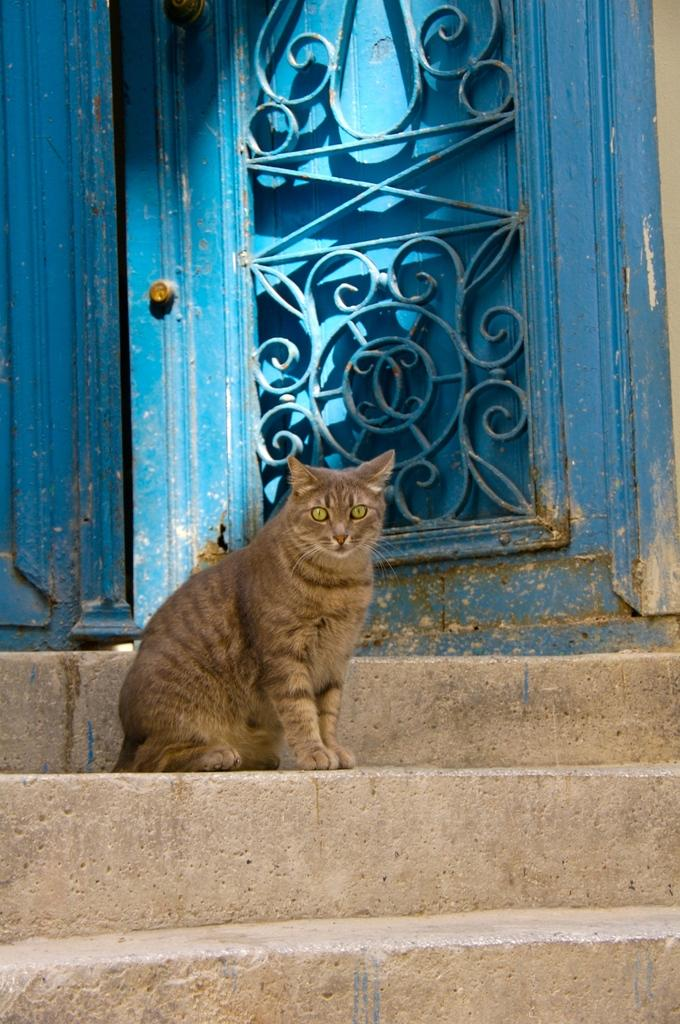What type of animal is in the image? There is a cat in the image. Where is the cat located in the image? The cat is on a staircase. What other object can be seen in the image? There is a door in the image. What color is the door? The door is blue. What is the cat's reaction to the zebra in the image? There is no zebra present in the image, so the cat's reaction cannot be determined. 